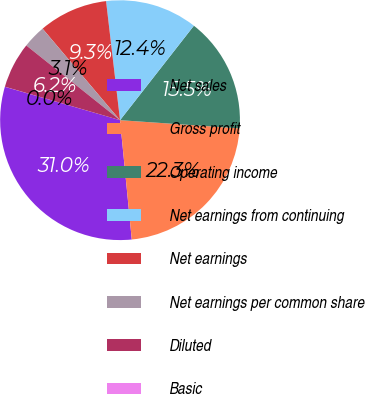Convert chart to OTSL. <chart><loc_0><loc_0><loc_500><loc_500><pie_chart><fcel>Net sales<fcel>Gross profit<fcel>Operating income<fcel>Net earnings from continuing<fcel>Net earnings<fcel>Net earnings per common share<fcel>Diluted<fcel>Basic<nl><fcel>31.05%<fcel>22.35%<fcel>15.53%<fcel>12.42%<fcel>9.32%<fcel>3.11%<fcel>6.21%<fcel>0.01%<nl></chart> 